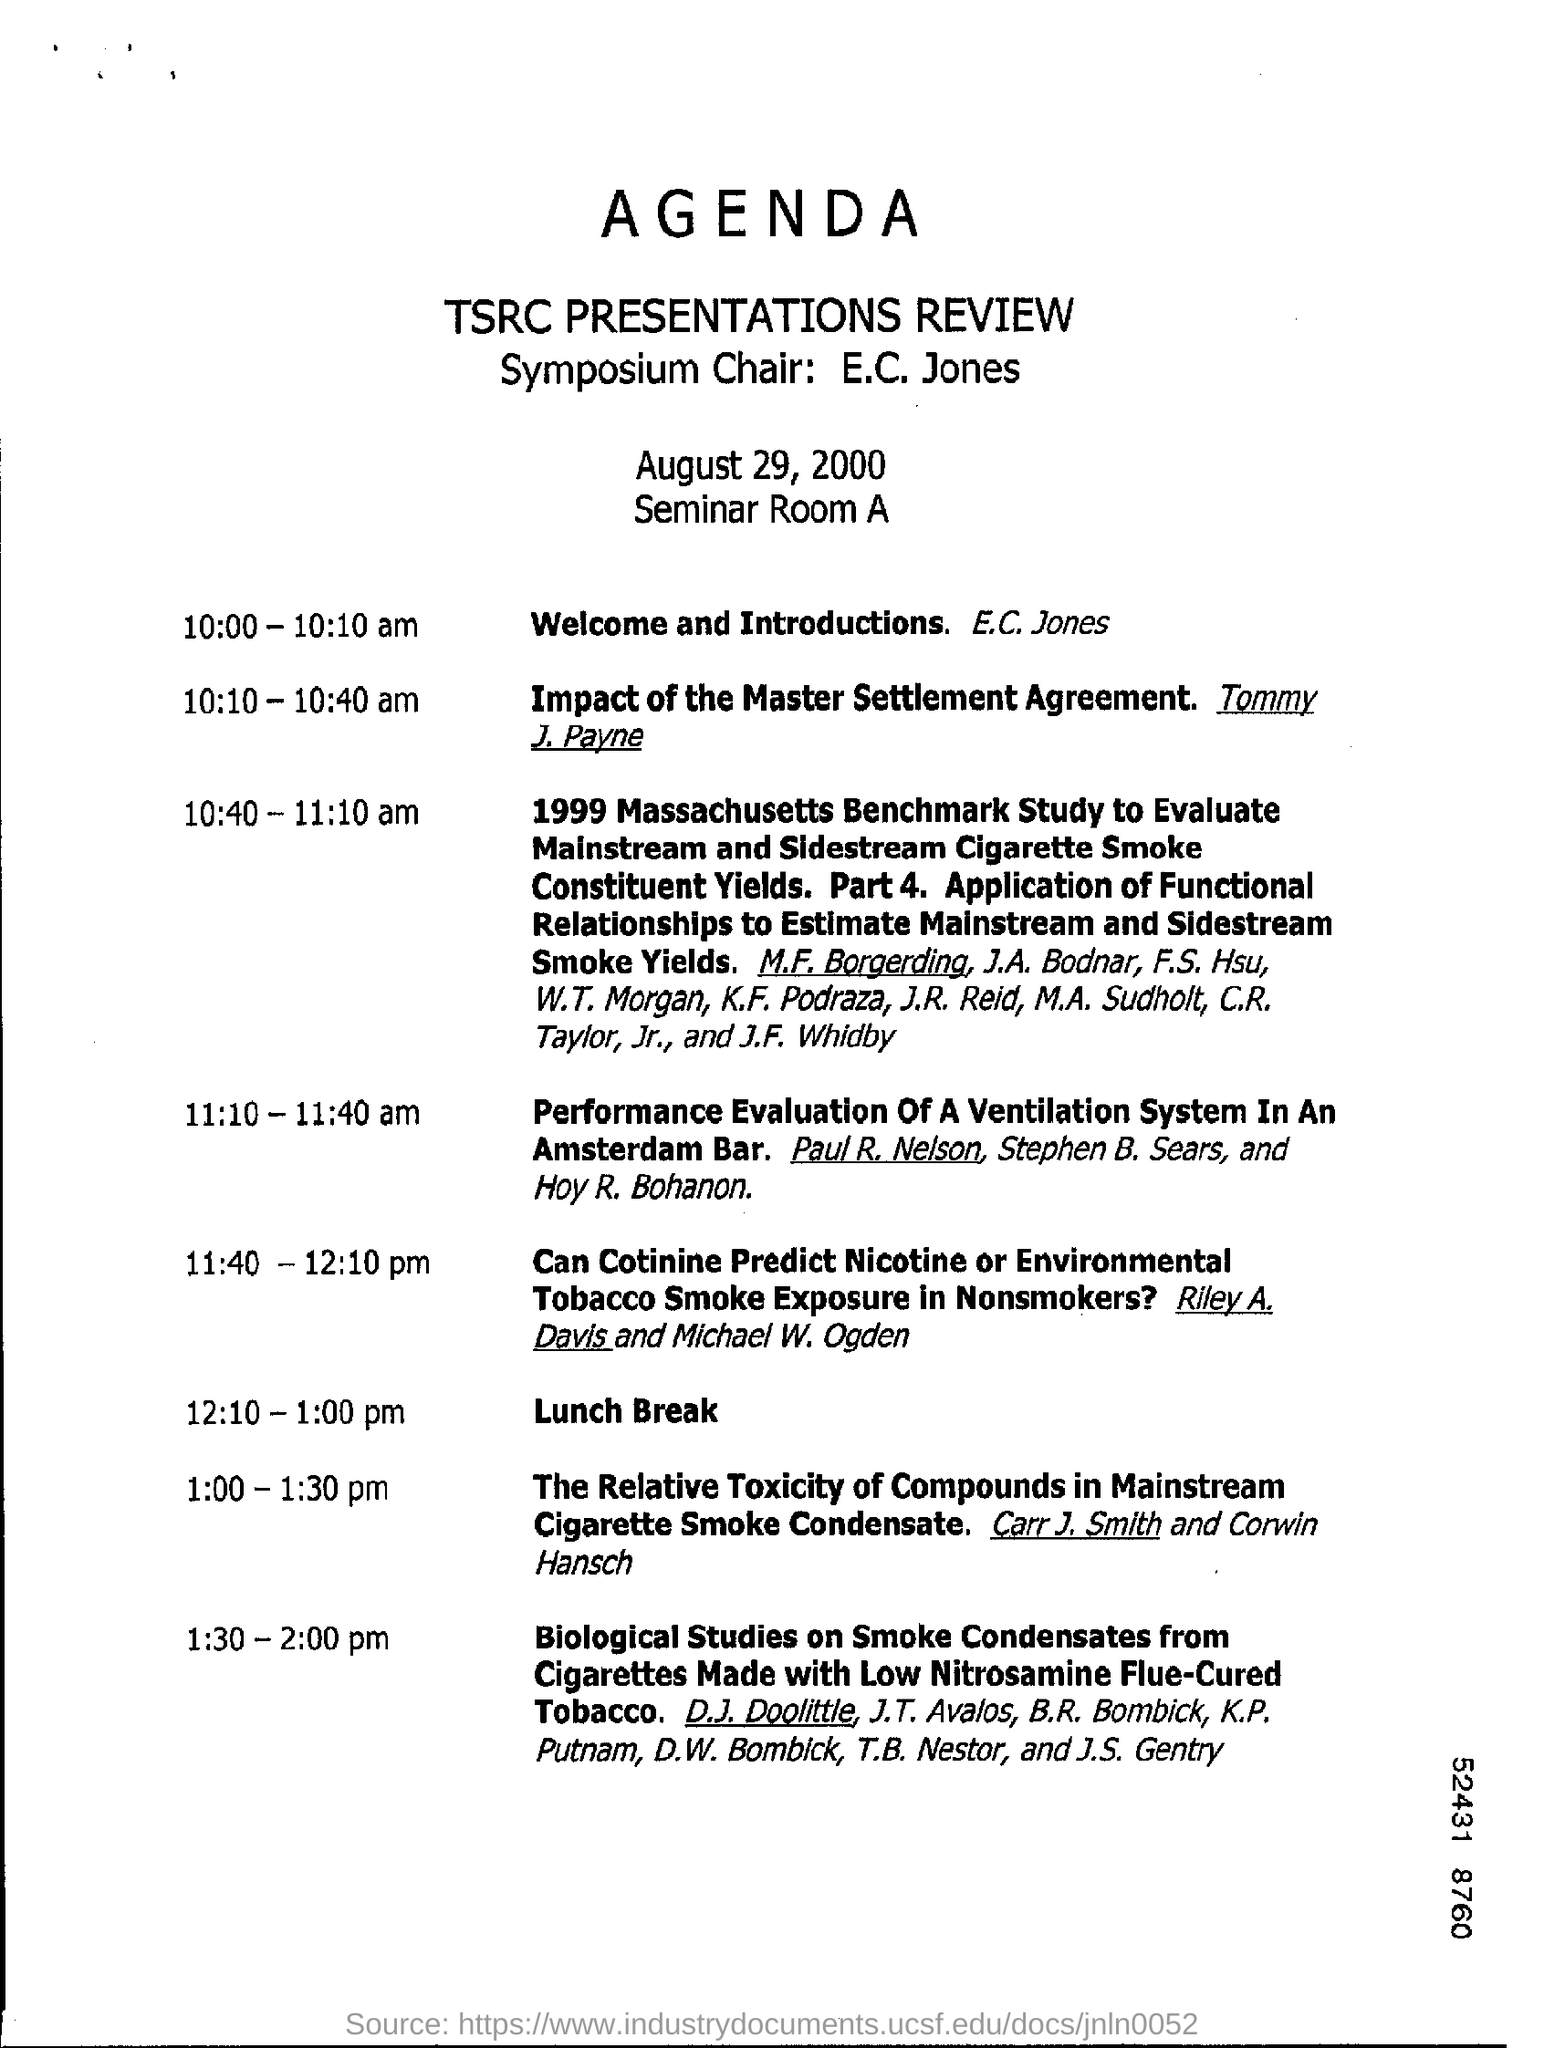Identify some key points in this picture. At 10:10-10:40 am, Tommy J. Payne is conducting the session. At 12:10 pm to 1:00 pm, a lunch break is provided. 